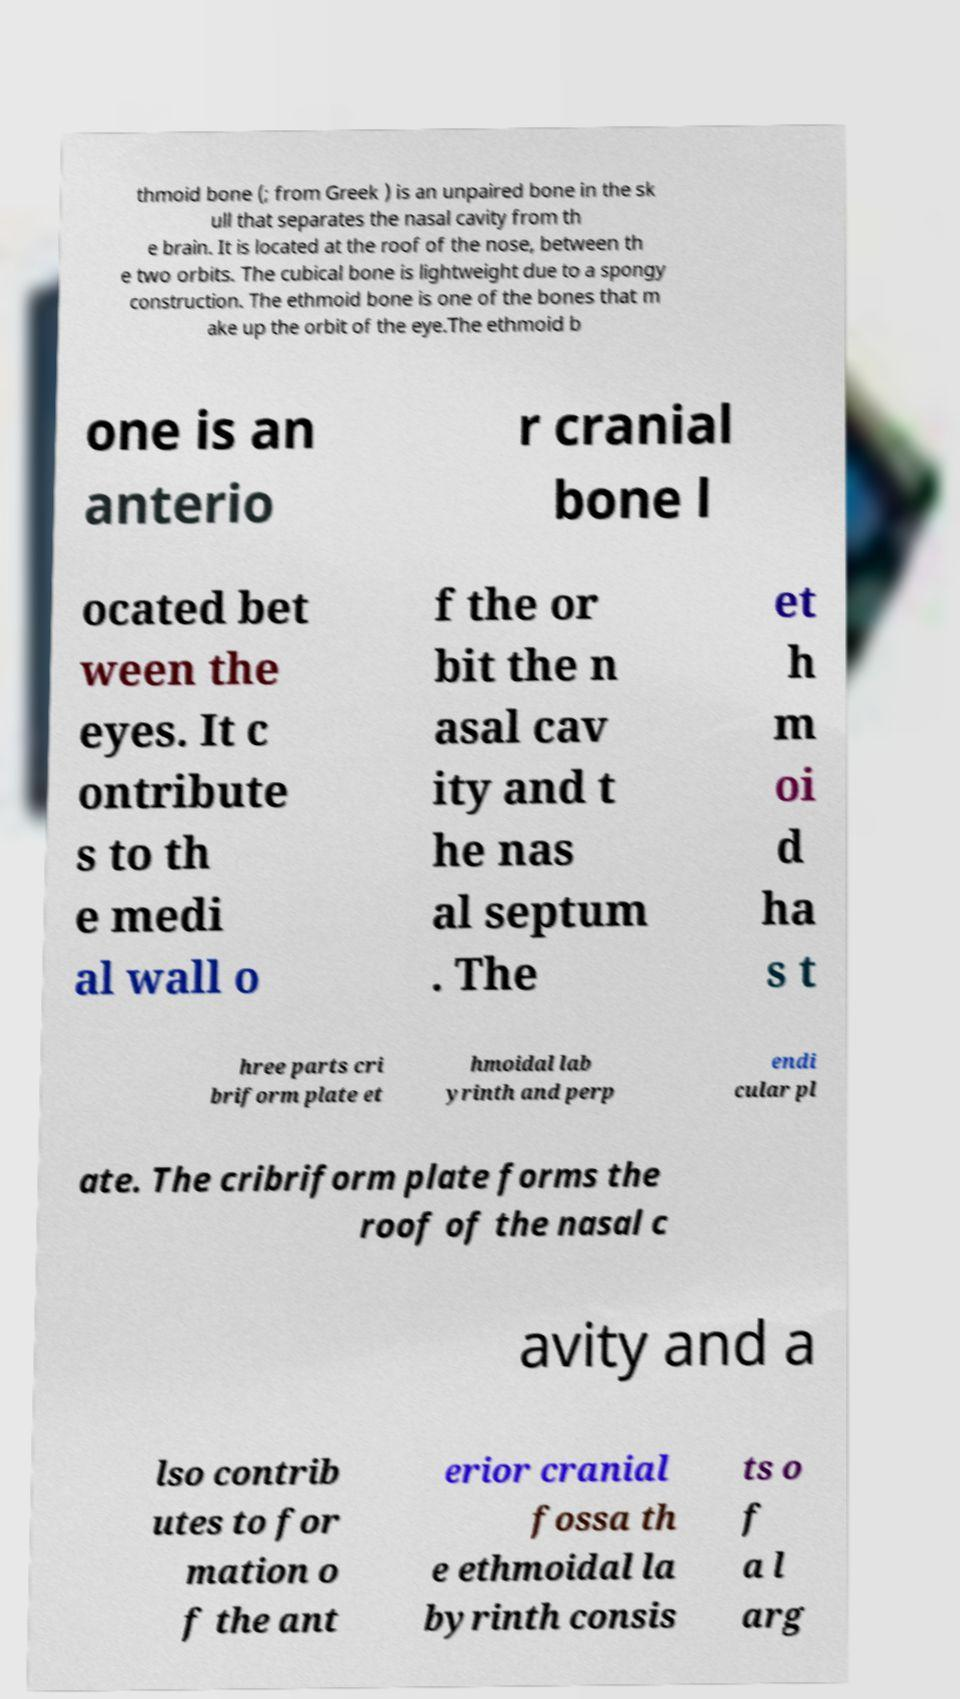Please read and relay the text visible in this image. What does it say? thmoid bone (; from Greek ) is an unpaired bone in the sk ull that separates the nasal cavity from th e brain. It is located at the roof of the nose, between th e two orbits. The cubical bone is lightweight due to a spongy construction. The ethmoid bone is one of the bones that m ake up the orbit of the eye.The ethmoid b one is an anterio r cranial bone l ocated bet ween the eyes. It c ontribute s to th e medi al wall o f the or bit the n asal cav ity and t he nas al septum . The et h m oi d ha s t hree parts cri briform plate et hmoidal lab yrinth and perp endi cular pl ate. The cribriform plate forms the roof of the nasal c avity and a lso contrib utes to for mation o f the ant erior cranial fossa th e ethmoidal la byrinth consis ts o f a l arg 